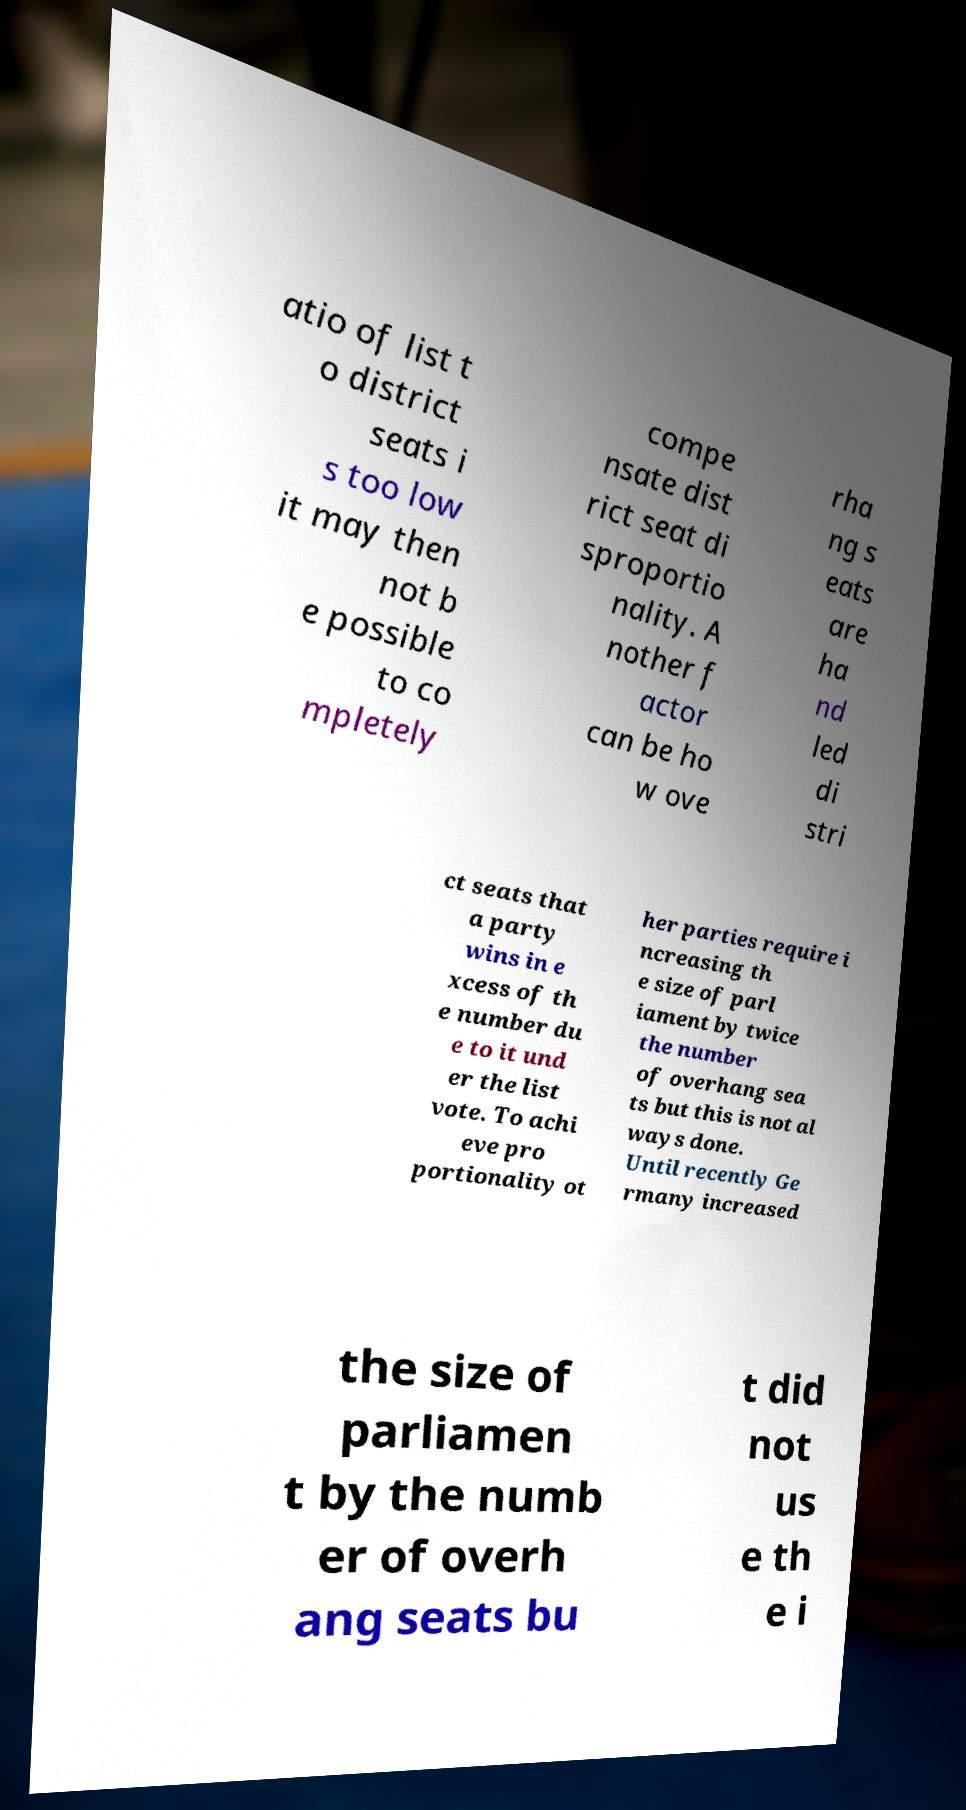There's text embedded in this image that I need extracted. Can you transcribe it verbatim? atio of list t o district seats i s too low it may then not b e possible to co mpletely compe nsate dist rict seat di sproportio nality. A nother f actor can be ho w ove rha ng s eats are ha nd led di stri ct seats that a party wins in e xcess of th e number du e to it und er the list vote. To achi eve pro portionality ot her parties require i ncreasing th e size of parl iament by twice the number of overhang sea ts but this is not al ways done. Until recently Ge rmany increased the size of parliamen t by the numb er of overh ang seats bu t did not us e th e i 